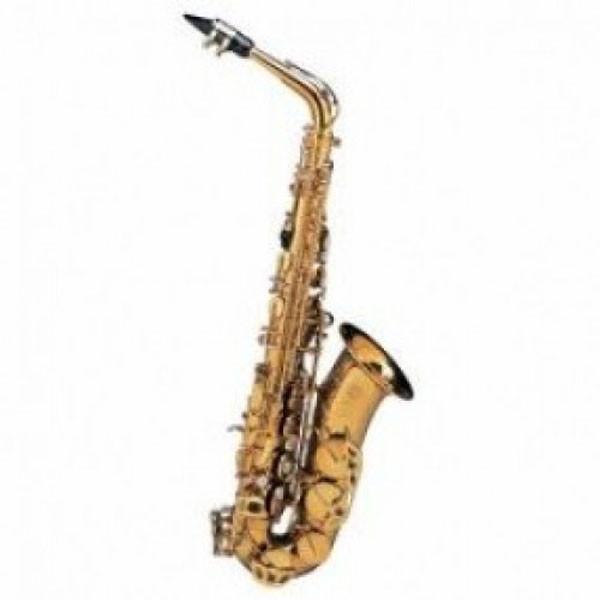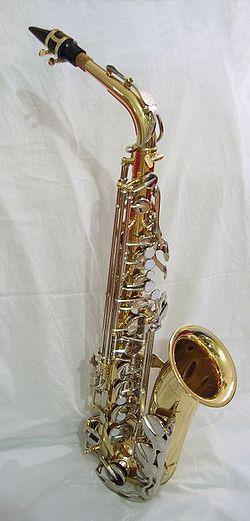The first image is the image on the left, the second image is the image on the right. Evaluate the accuracy of this statement regarding the images: "Each image contains one saxophone displayed with its bell facing rightward and its mouthpiece pointing leftward, and each saxophone has a curved bell end.". Is it true? Answer yes or no. Yes. The first image is the image on the left, the second image is the image on the right. Considering the images on both sides, is "There are exactly two saxophones with their mouthpiece pointing to the left." valid? Answer yes or no. Yes. 